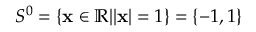Convert formula to latex. <formula><loc_0><loc_0><loc_500><loc_500>S ^ { 0 } = \{ { x } \in \mathbb { R } | | { x } | = 1 \} = \{ - 1 , 1 \}</formula> 